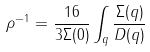Convert formula to latex. <formula><loc_0><loc_0><loc_500><loc_500>\rho ^ { - 1 } = \frac { 1 6 } { 3 \Sigma ( 0 ) } \int _ { q } \frac { \Sigma ( q ) } { D ( q ) }</formula> 